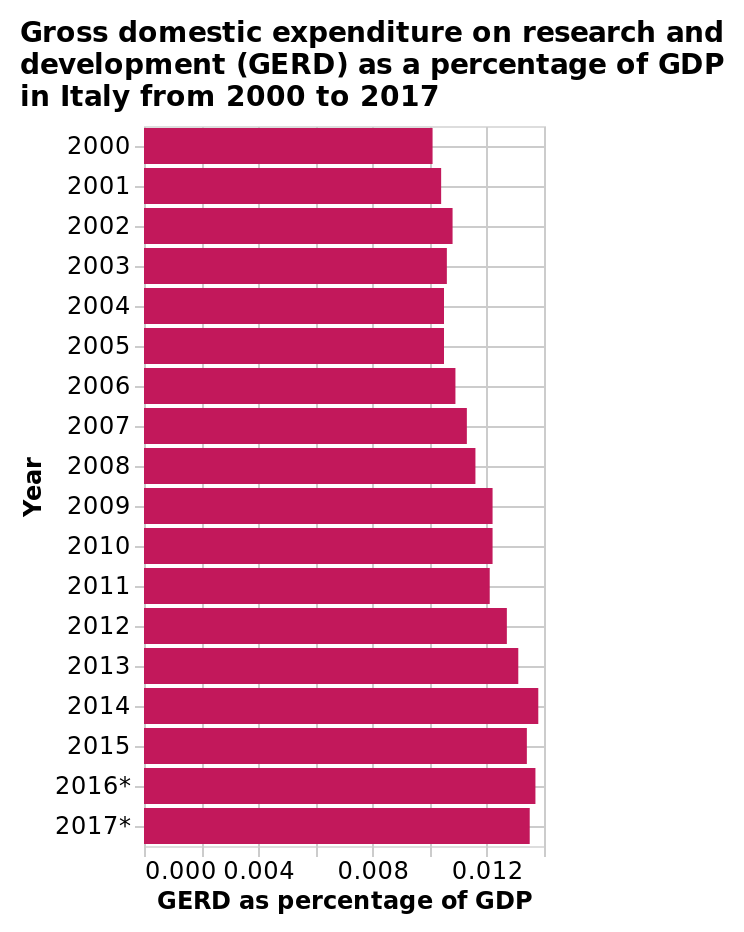<image>
please enumerates aspects of the construction of the chart This is a bar graph titled Gross domestic expenditure on research and development (GERD) as a percentage of GDP in Italy from 2000 to 2017. The y-axis shows Year while the x-axis measures GERD as percentage of GDP. 